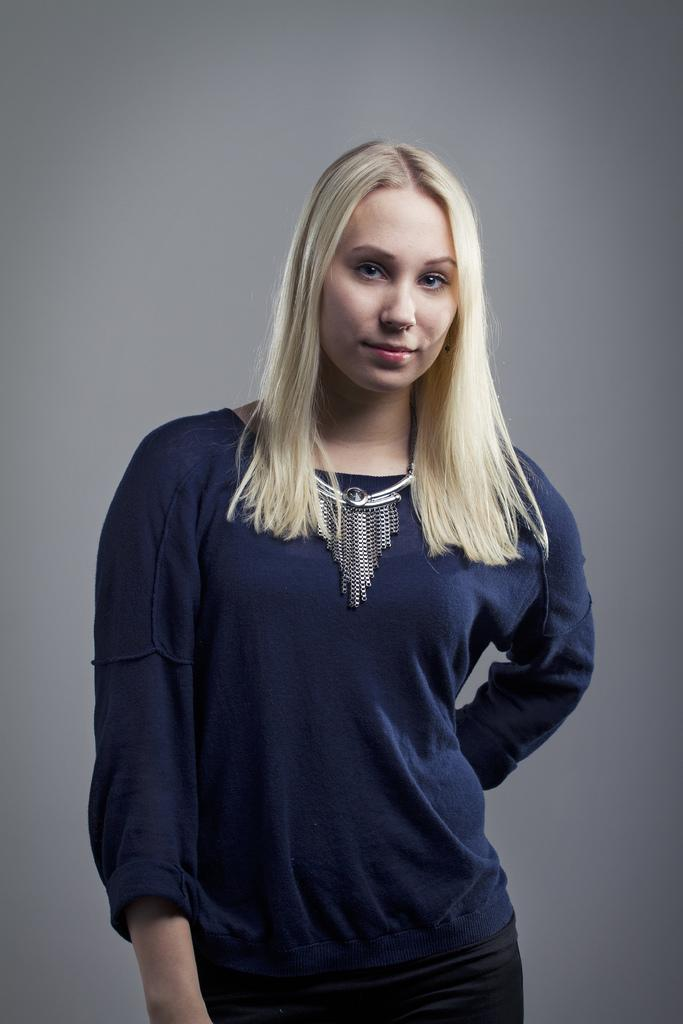Who is in the image? There is a woman in the image. What is the woman wearing? The woman is wearing a t-shirt and a necklace. What is the woman's facial expression? The woman is smiling. Where is the woman located in the image? The woman is standing near a wall. What type of wool is the woman using in the image? There is no wool present in the image, and the woman is not using any wool. 